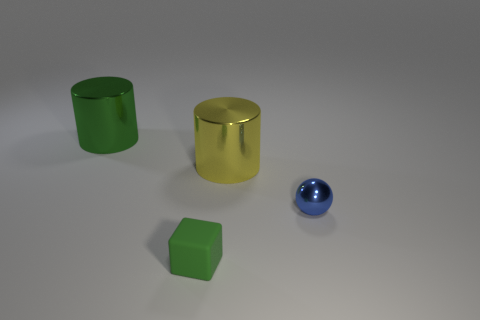What number of cylinders have the same color as the small block?
Ensure brevity in your answer.  1. The green thing behind the small green block has what shape?
Make the answer very short. Cylinder. Do the big cylinder that is behind the big yellow cylinder and the big object in front of the big green metal object have the same material?
Keep it short and to the point. Yes. Is there a large green object of the same shape as the small blue object?
Your answer should be compact. No. What number of things are metal things in front of the yellow metallic object or small red matte spheres?
Give a very brief answer. 1. Is the number of big yellow metallic cylinders in front of the big yellow object greater than the number of blocks behind the block?
Provide a succinct answer. No. What number of metal things are cylinders or yellow cylinders?
Your response must be concise. 2. There is a big thing that is the same color as the small matte object; what is it made of?
Your answer should be compact. Metal. Is the number of large yellow objects behind the large green shiny cylinder less than the number of matte things in front of the block?
Your answer should be compact. No. What number of things are green cubes or big metal cylinders to the left of the small block?
Your response must be concise. 2. 